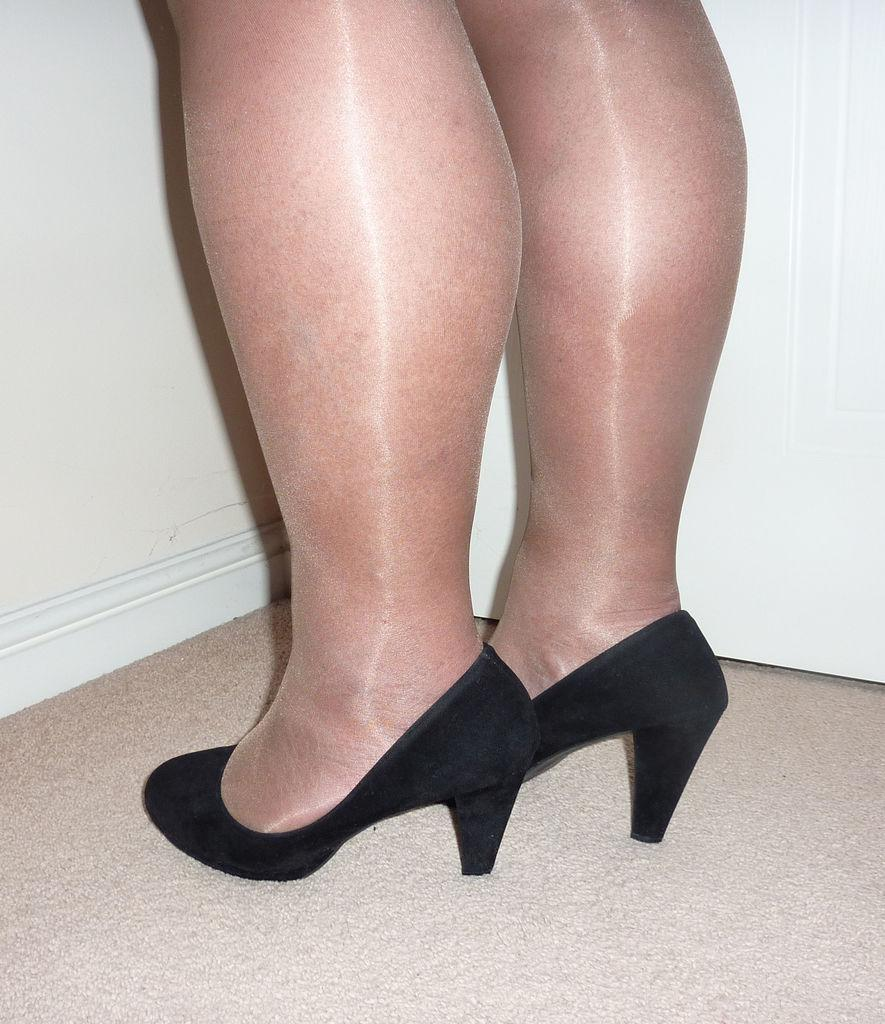Who or what is present in the image? There is a person in the image. What part of the person's body can be seen? The person's legs are visible. What type of footwear is the person wearing? The person is wearing black color shoes. What color is the wall in the image? There is a white color wall in the image. What type of playground equipment can be seen in the image? There is no playground equipment present in the image. What territory does the person in the image belong to? The image does not provide information about the person's territory or nationality. 